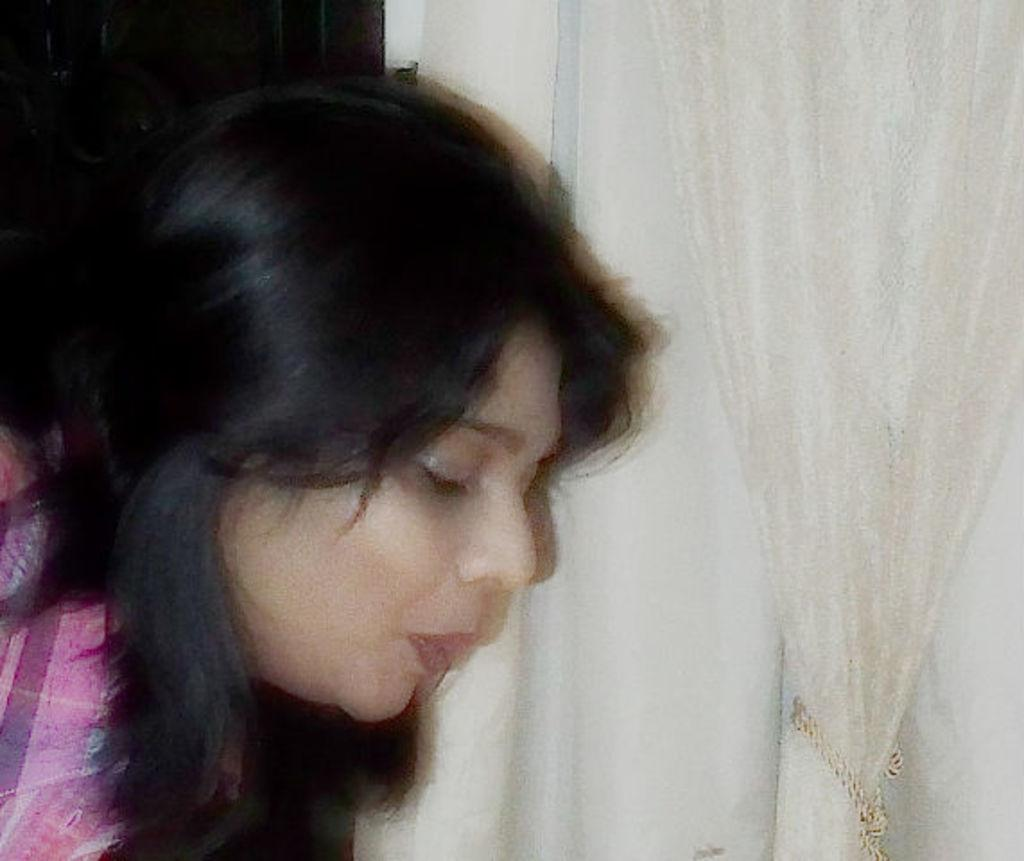Who is present in the image? There is a woman in the image. What is the woman wearing? The woman is wearing a pink dress. What can be seen on the right side of the image? There is a curtain on the right side of the image. What color is the curtain? The curtain is white in color. What time of day is it in the image, and who is the stranger that the woman is talking to? The provided facts do not mention the time of day or the presence of a stranger in the image. 